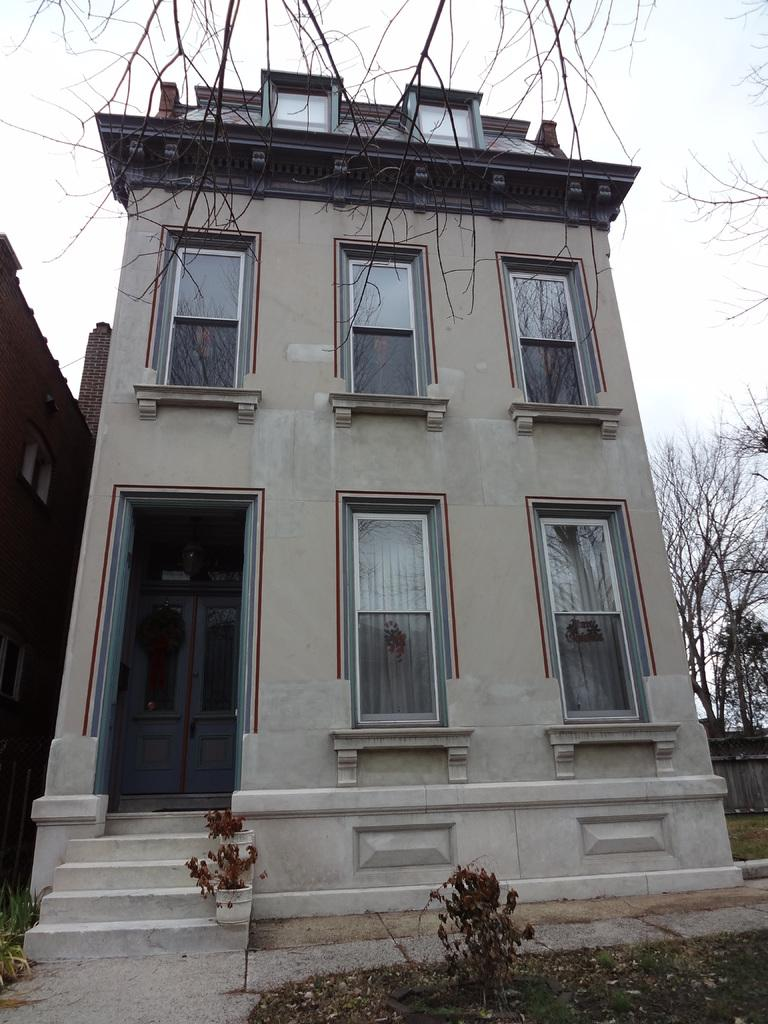What is the main structure in the image? There is a building in the middle of the image. What can be seen in the distance behind the building? There are trees in the background of the image. Is there any vegetation closer to the viewer in the image? Yes, there is a plant at the bottom of the image. What type of cactus can be seen coughing in the image? There is no cactus present in the image, and cacti do not have the ability to cough. 